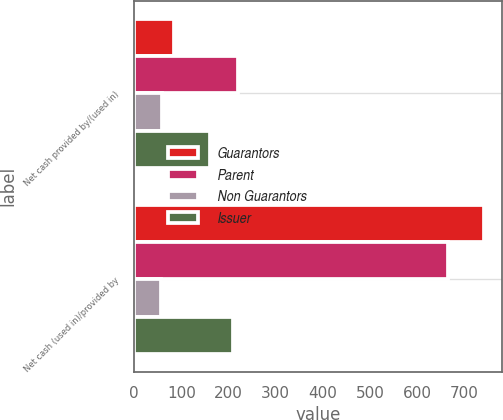<chart> <loc_0><loc_0><loc_500><loc_500><stacked_bar_chart><ecel><fcel>Net cash provided by/(used in)<fcel>Net cash (used in)/provided by<nl><fcel>Guarantors<fcel>84.4<fcel>742.4<nl><fcel>Parent<fcel>219.8<fcel>665.2<nl><fcel>Non Guarantors<fcel>58.4<fcel>57.5<nl><fcel>Issuer<fcel>161.1<fcel>209.7<nl></chart> 